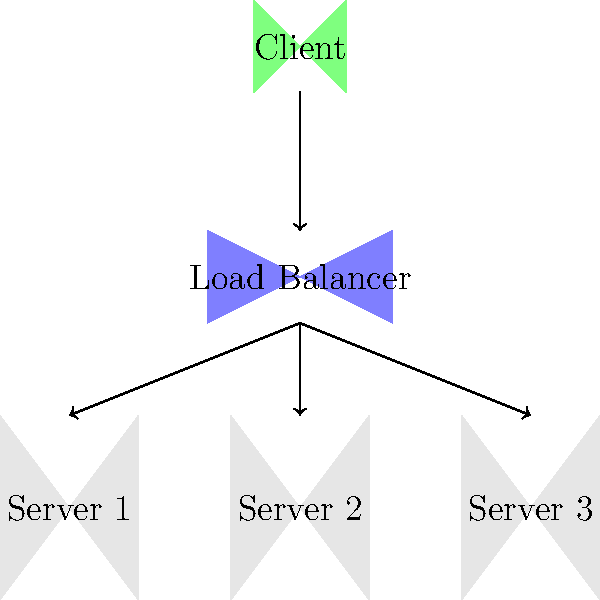In the Ubuntu server distribution diagram shown above, which load balancing algorithm would be most suitable for distributing incoming traffic evenly across all three servers, assuming they have identical hardware specifications and are running the same applications? To determine the most suitable load balancing algorithm for this scenario, let's consider the following steps:

1. Analyze the diagram:
   - We have one load balancer
   - There are three identical servers (Server 1, Server 2, and Server 3)
   - A single client is sending requests to the load balancer

2. Consider the given information:
   - All servers have identical hardware specifications
   - All servers are running the same applications

3. Evaluate common load balancing algorithms:
   a) Round Robin: Distributes requests sequentially to each server in turn
   b) Least Connections: Sends requests to the server with the fewest active connections
   c) IP Hash: Uses the client's IP address to determine which server to use
   d) Weighted Round Robin: Similar to Round Robin, but with weighted distribution

4. Analyze the suitability of each algorithm:
   a) Round Robin:
      - Pros: Simple, distributes requests evenly
      - Cons: Doesn't consider server load or connection state
   b) Least Connections:
      - Pros: Considers current server load
      - Cons: May not be necessary if servers have identical specs and applications
   c) IP Hash:
      - Pros: Ensures session persistence
      - Cons: May lead to uneven distribution if client IPs are not diverse
   d) Weighted Round Robin:
      - Pros: Allows for fine-tuned distribution
      - Cons: Not necessary when servers have identical capabilities

5. Choose the most suitable algorithm:
   Given that all servers have identical hardware and are running the same applications, the simplest and most effective algorithm for even distribution would be Round Robin.

Round Robin will distribute incoming requests sequentially and evenly across all three servers, ensuring an equal distribution of traffic without unnecessary complexity.
Answer: Round Robin 